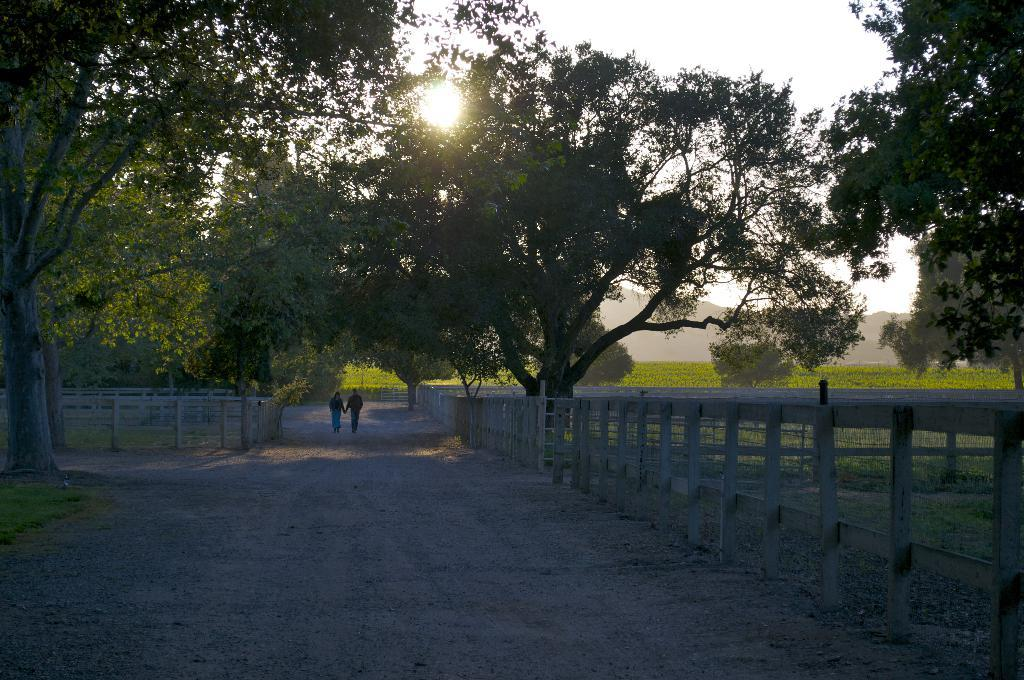What is the main feature of the image? There is a road in the image. What are the people in the image doing? Two persons are standing on the road. What can be seen near the road? There is a railing in the image. What type of vegetation is present in the image? There are trees and grass in the image. What is visible in the background of the image? There is a mountain and the sky in the background of the image. Can the sun be seen in the image? Yes, the sun is observable in the sky. What type of store can be seen in the image? There is no store present in the image. What is the wealth status of the society depicted in the image? There is no indication of a society or wealth status in the image. 